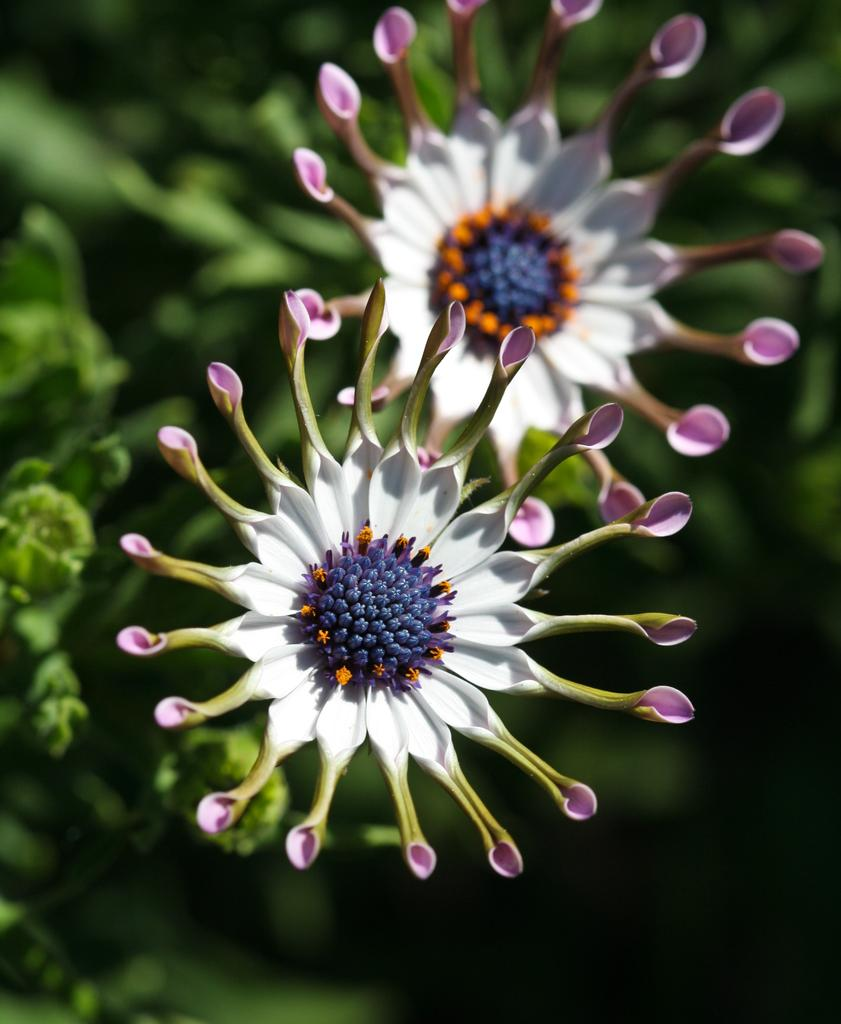What is the main subject of the image? The main subject of the image is flowers. Where are the flowers located in the image? The flowers are in the center of the image. Can you describe the background of the image? The background of the image is blurry. What type of battle is taking place in the background of the image? There is no battle present in the image; the background is a blurry background is mentioned, but no specific event or activity is depicted. 